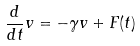Convert formula to latex. <formula><loc_0><loc_0><loc_500><loc_500>\frac { d } { d t } v = - \gamma v + F ( t )</formula> 